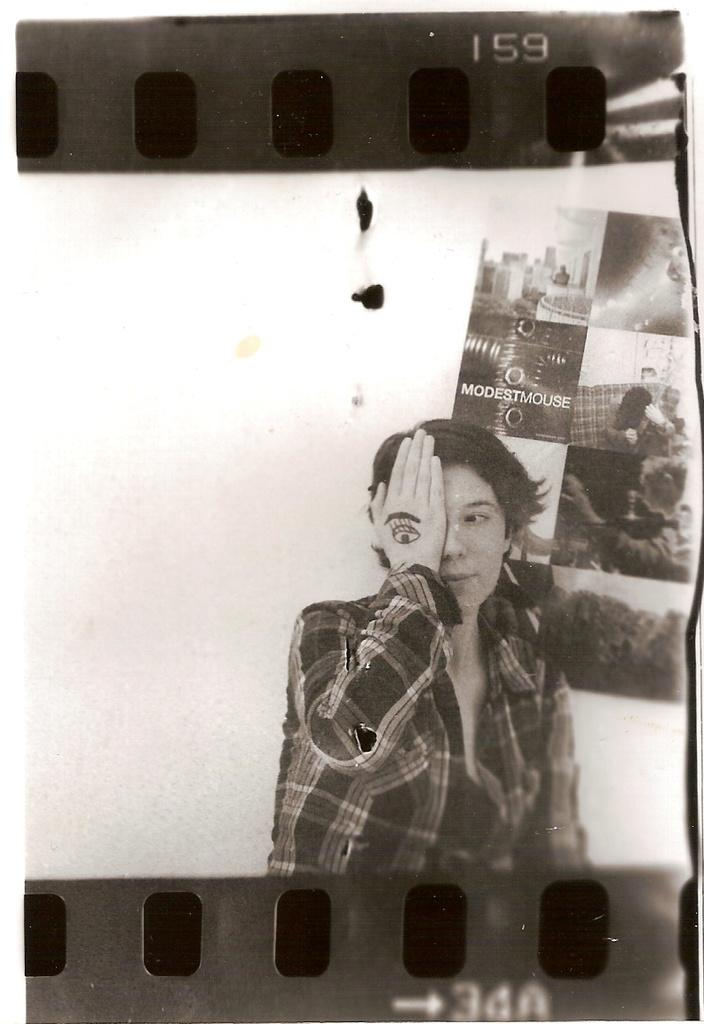What is the main object in the image? There is a negative reel in the image. What is happening inside the negative reel? A person is present in the negative reel, and they are keeping a hand on their eye. What can be seen in the background of the image? There are posters visible behind the person. What type of school is the visitor representing in the image? There is no school or visitor present in the image; it features a negative reel with a person keeping a hand on their eye and posters in the background. 